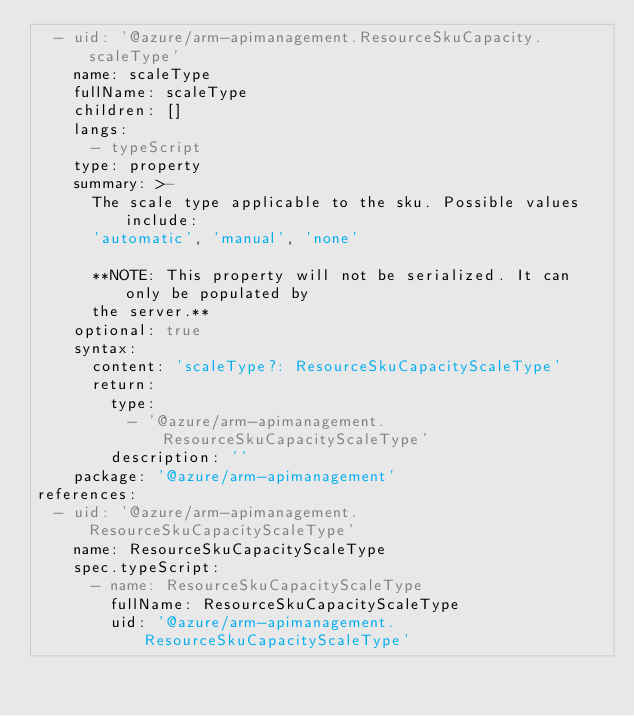Convert code to text. <code><loc_0><loc_0><loc_500><loc_500><_YAML_>  - uid: '@azure/arm-apimanagement.ResourceSkuCapacity.scaleType'
    name: scaleType
    fullName: scaleType
    children: []
    langs:
      - typeScript
    type: property
    summary: >-
      The scale type applicable to the sku. Possible values include:
      'automatic', 'manual', 'none'

      **NOTE: This property will not be serialized. It can only be populated by
      the server.**
    optional: true
    syntax:
      content: 'scaleType?: ResourceSkuCapacityScaleType'
      return:
        type:
          - '@azure/arm-apimanagement.ResourceSkuCapacityScaleType'
        description: ''
    package: '@azure/arm-apimanagement'
references:
  - uid: '@azure/arm-apimanagement.ResourceSkuCapacityScaleType'
    name: ResourceSkuCapacityScaleType
    spec.typeScript:
      - name: ResourceSkuCapacityScaleType
        fullName: ResourceSkuCapacityScaleType
        uid: '@azure/arm-apimanagement.ResourceSkuCapacityScaleType'
</code> 